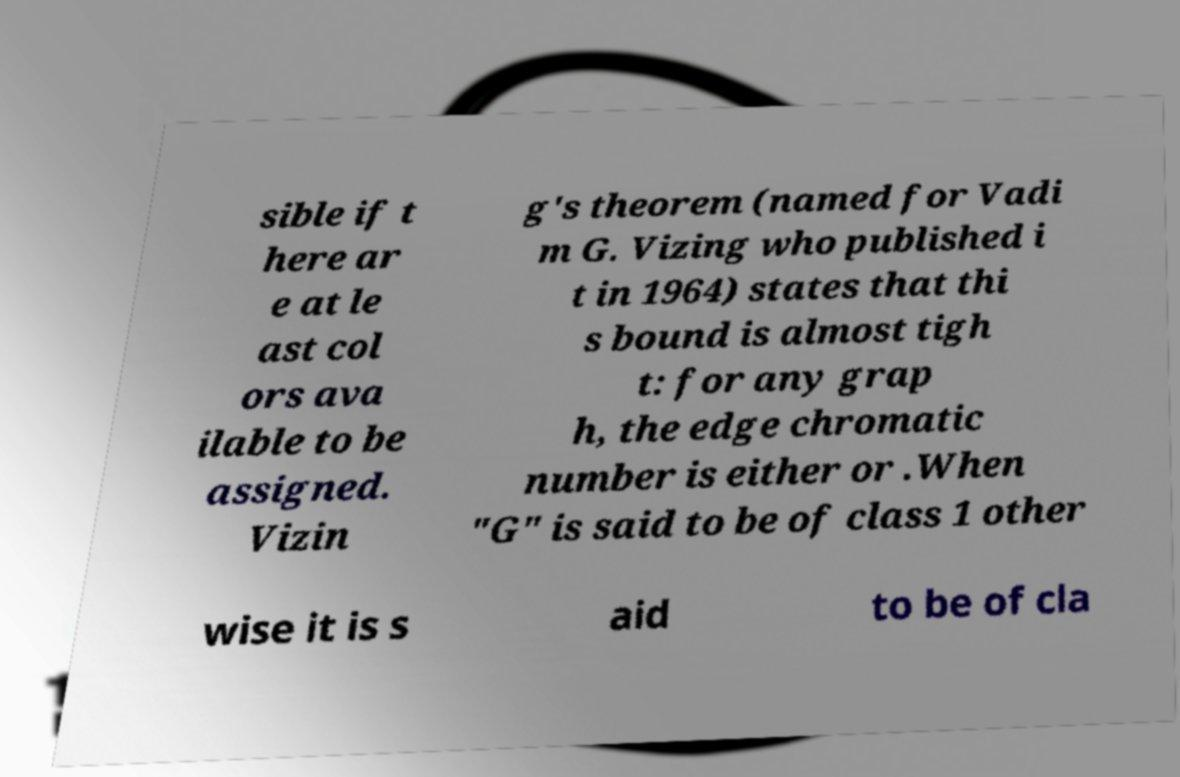What messages or text are displayed in this image? I need them in a readable, typed format. sible if t here ar e at le ast col ors ava ilable to be assigned. Vizin g's theorem (named for Vadi m G. Vizing who published i t in 1964) states that thi s bound is almost tigh t: for any grap h, the edge chromatic number is either or .When "G" is said to be of class 1 other wise it is s aid to be of cla 